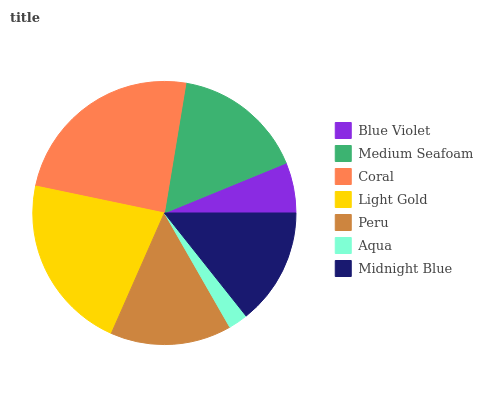Is Aqua the minimum?
Answer yes or no. Yes. Is Coral the maximum?
Answer yes or no. Yes. Is Medium Seafoam the minimum?
Answer yes or no. No. Is Medium Seafoam the maximum?
Answer yes or no. No. Is Medium Seafoam greater than Blue Violet?
Answer yes or no. Yes. Is Blue Violet less than Medium Seafoam?
Answer yes or no. Yes. Is Blue Violet greater than Medium Seafoam?
Answer yes or no. No. Is Medium Seafoam less than Blue Violet?
Answer yes or no. No. Is Peru the high median?
Answer yes or no. Yes. Is Peru the low median?
Answer yes or no. Yes. Is Blue Violet the high median?
Answer yes or no. No. Is Coral the low median?
Answer yes or no. No. 